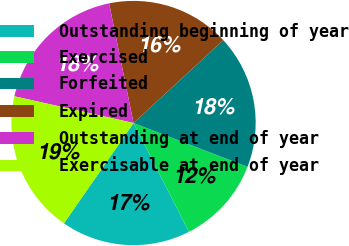Convert chart to OTSL. <chart><loc_0><loc_0><loc_500><loc_500><pie_chart><fcel>Outstanding beginning of year<fcel>Exercised<fcel>Forfeited<fcel>Expired<fcel>Outstanding at end of year<fcel>Exercisable at end of year<nl><fcel>17.14%<fcel>11.67%<fcel>17.71%<fcel>16.34%<fcel>18.28%<fcel>18.86%<nl></chart> 